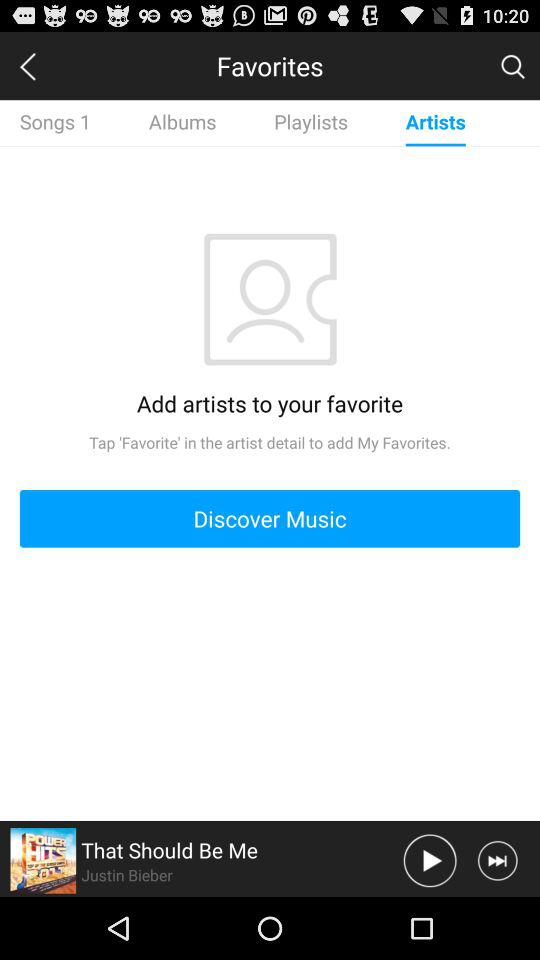Which song is playing on the screen? The song playing on the screen is "That Should Be Me". 